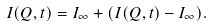Convert formula to latex. <formula><loc_0><loc_0><loc_500><loc_500>I ( Q , t ) = I _ { \infty } + ( I ( Q , t ) - I _ { \infty } ) .</formula> 